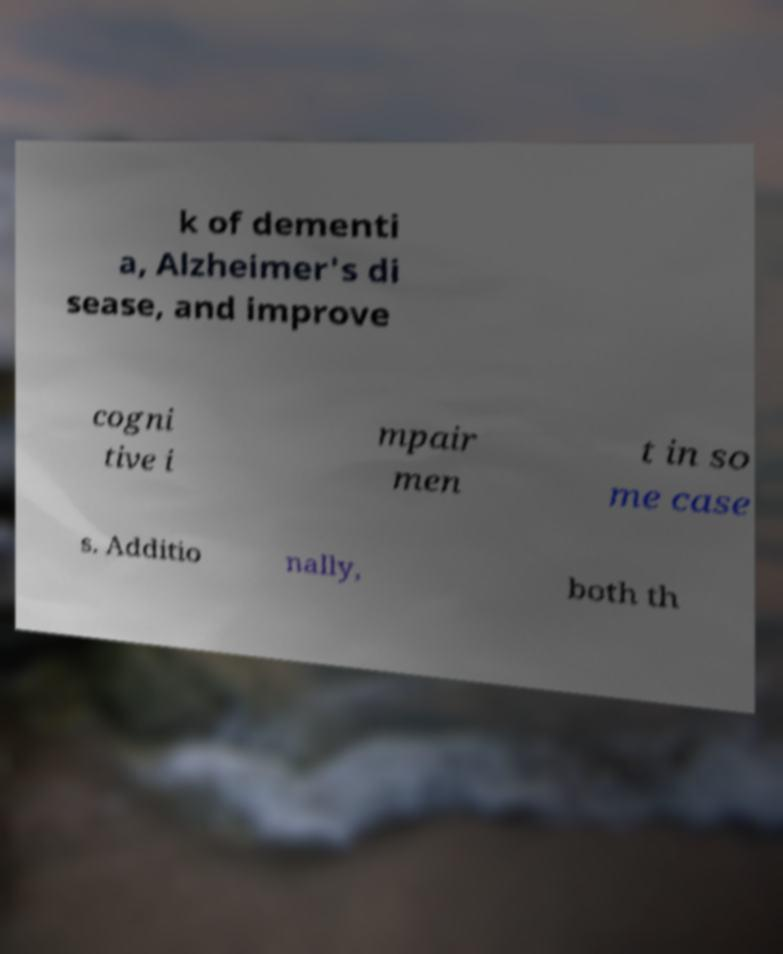Could you assist in decoding the text presented in this image and type it out clearly? k of dementi a, Alzheimer's di sease, and improve cogni tive i mpair men t in so me case s. Additio nally, both th 